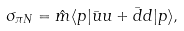<formula> <loc_0><loc_0><loc_500><loc_500>\sigma _ { \pi N } = \hat { m } \langle p | \bar { u } u + \bar { d } d | p \rangle ,</formula> 